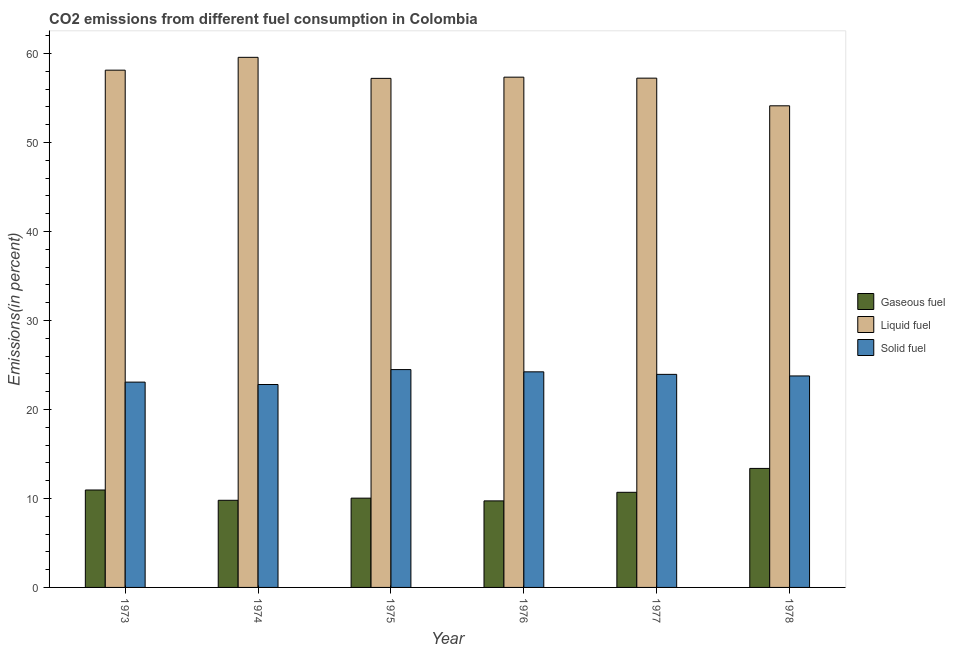How many different coloured bars are there?
Your answer should be compact. 3. Are the number of bars per tick equal to the number of legend labels?
Your response must be concise. Yes. Are the number of bars on each tick of the X-axis equal?
Ensure brevity in your answer.  Yes. What is the label of the 6th group of bars from the left?
Make the answer very short. 1978. What is the percentage of gaseous fuel emission in 1974?
Give a very brief answer. 9.79. Across all years, what is the maximum percentage of gaseous fuel emission?
Keep it short and to the point. 13.37. Across all years, what is the minimum percentage of liquid fuel emission?
Your answer should be very brief. 54.11. In which year was the percentage of gaseous fuel emission maximum?
Ensure brevity in your answer.  1978. In which year was the percentage of liquid fuel emission minimum?
Give a very brief answer. 1978. What is the total percentage of liquid fuel emission in the graph?
Make the answer very short. 343.54. What is the difference between the percentage of solid fuel emission in 1976 and that in 1977?
Keep it short and to the point. 0.28. What is the difference between the percentage of gaseous fuel emission in 1975 and the percentage of solid fuel emission in 1977?
Provide a short and direct response. -0.66. What is the average percentage of gaseous fuel emission per year?
Ensure brevity in your answer.  10.76. In the year 1974, what is the difference between the percentage of gaseous fuel emission and percentage of liquid fuel emission?
Give a very brief answer. 0. In how many years, is the percentage of solid fuel emission greater than 30 %?
Make the answer very short. 0. What is the ratio of the percentage of gaseous fuel emission in 1975 to that in 1976?
Offer a very short reply. 1.03. Is the difference between the percentage of solid fuel emission in 1973 and 1974 greater than the difference between the percentage of gaseous fuel emission in 1973 and 1974?
Offer a terse response. No. What is the difference between the highest and the second highest percentage of liquid fuel emission?
Offer a very short reply. 1.44. What is the difference between the highest and the lowest percentage of liquid fuel emission?
Your answer should be compact. 5.45. What does the 3rd bar from the left in 1977 represents?
Your answer should be very brief. Solid fuel. What does the 1st bar from the right in 1975 represents?
Offer a very short reply. Solid fuel. Is it the case that in every year, the sum of the percentage of gaseous fuel emission and percentage of liquid fuel emission is greater than the percentage of solid fuel emission?
Give a very brief answer. Yes. How many bars are there?
Provide a short and direct response. 18. Are all the bars in the graph horizontal?
Your response must be concise. No. What is the difference between two consecutive major ticks on the Y-axis?
Ensure brevity in your answer.  10. Does the graph contain grids?
Provide a short and direct response. No. Where does the legend appear in the graph?
Provide a succinct answer. Center right. How many legend labels are there?
Offer a terse response. 3. How are the legend labels stacked?
Offer a very short reply. Vertical. What is the title of the graph?
Make the answer very short. CO2 emissions from different fuel consumption in Colombia. What is the label or title of the Y-axis?
Offer a very short reply. Emissions(in percent). What is the Emissions(in percent) in Gaseous fuel in 1973?
Give a very brief answer. 10.95. What is the Emissions(in percent) in Liquid fuel in 1973?
Make the answer very short. 58.12. What is the Emissions(in percent) in Solid fuel in 1973?
Provide a short and direct response. 23.07. What is the Emissions(in percent) of Gaseous fuel in 1974?
Ensure brevity in your answer.  9.79. What is the Emissions(in percent) of Liquid fuel in 1974?
Keep it short and to the point. 59.56. What is the Emissions(in percent) of Solid fuel in 1974?
Make the answer very short. 22.8. What is the Emissions(in percent) in Gaseous fuel in 1975?
Make the answer very short. 10.03. What is the Emissions(in percent) in Liquid fuel in 1975?
Your answer should be very brief. 57.2. What is the Emissions(in percent) of Solid fuel in 1975?
Ensure brevity in your answer.  24.48. What is the Emissions(in percent) of Gaseous fuel in 1976?
Keep it short and to the point. 9.72. What is the Emissions(in percent) of Liquid fuel in 1976?
Your answer should be compact. 57.33. What is the Emissions(in percent) of Solid fuel in 1976?
Give a very brief answer. 24.22. What is the Emissions(in percent) of Gaseous fuel in 1977?
Ensure brevity in your answer.  10.69. What is the Emissions(in percent) of Liquid fuel in 1977?
Offer a terse response. 57.22. What is the Emissions(in percent) of Solid fuel in 1977?
Give a very brief answer. 23.94. What is the Emissions(in percent) of Gaseous fuel in 1978?
Provide a short and direct response. 13.37. What is the Emissions(in percent) in Liquid fuel in 1978?
Offer a terse response. 54.11. What is the Emissions(in percent) of Solid fuel in 1978?
Give a very brief answer. 23.76. Across all years, what is the maximum Emissions(in percent) of Gaseous fuel?
Your answer should be very brief. 13.37. Across all years, what is the maximum Emissions(in percent) in Liquid fuel?
Your answer should be compact. 59.56. Across all years, what is the maximum Emissions(in percent) in Solid fuel?
Your answer should be very brief. 24.48. Across all years, what is the minimum Emissions(in percent) in Gaseous fuel?
Provide a short and direct response. 9.72. Across all years, what is the minimum Emissions(in percent) in Liquid fuel?
Offer a terse response. 54.11. Across all years, what is the minimum Emissions(in percent) in Solid fuel?
Keep it short and to the point. 22.8. What is the total Emissions(in percent) of Gaseous fuel in the graph?
Keep it short and to the point. 64.55. What is the total Emissions(in percent) in Liquid fuel in the graph?
Give a very brief answer. 343.54. What is the total Emissions(in percent) in Solid fuel in the graph?
Your answer should be compact. 142.27. What is the difference between the Emissions(in percent) in Gaseous fuel in 1973 and that in 1974?
Your response must be concise. 1.16. What is the difference between the Emissions(in percent) of Liquid fuel in 1973 and that in 1974?
Provide a short and direct response. -1.44. What is the difference between the Emissions(in percent) in Solid fuel in 1973 and that in 1974?
Provide a short and direct response. 0.27. What is the difference between the Emissions(in percent) of Gaseous fuel in 1973 and that in 1975?
Ensure brevity in your answer.  0.92. What is the difference between the Emissions(in percent) of Liquid fuel in 1973 and that in 1975?
Offer a very short reply. 0.92. What is the difference between the Emissions(in percent) of Solid fuel in 1973 and that in 1975?
Ensure brevity in your answer.  -1.41. What is the difference between the Emissions(in percent) in Gaseous fuel in 1973 and that in 1976?
Your answer should be very brief. 1.22. What is the difference between the Emissions(in percent) in Liquid fuel in 1973 and that in 1976?
Ensure brevity in your answer.  0.79. What is the difference between the Emissions(in percent) in Solid fuel in 1973 and that in 1976?
Offer a terse response. -1.15. What is the difference between the Emissions(in percent) in Gaseous fuel in 1973 and that in 1977?
Give a very brief answer. 0.26. What is the difference between the Emissions(in percent) in Liquid fuel in 1973 and that in 1977?
Provide a succinct answer. 0.9. What is the difference between the Emissions(in percent) of Solid fuel in 1973 and that in 1977?
Offer a very short reply. -0.87. What is the difference between the Emissions(in percent) of Gaseous fuel in 1973 and that in 1978?
Your response must be concise. -2.43. What is the difference between the Emissions(in percent) of Liquid fuel in 1973 and that in 1978?
Offer a very short reply. 4. What is the difference between the Emissions(in percent) of Solid fuel in 1973 and that in 1978?
Make the answer very short. -0.69. What is the difference between the Emissions(in percent) in Gaseous fuel in 1974 and that in 1975?
Ensure brevity in your answer.  -0.24. What is the difference between the Emissions(in percent) in Liquid fuel in 1974 and that in 1975?
Your answer should be very brief. 2.36. What is the difference between the Emissions(in percent) in Solid fuel in 1974 and that in 1975?
Your response must be concise. -1.68. What is the difference between the Emissions(in percent) in Gaseous fuel in 1974 and that in 1976?
Your answer should be very brief. 0.07. What is the difference between the Emissions(in percent) of Liquid fuel in 1974 and that in 1976?
Ensure brevity in your answer.  2.23. What is the difference between the Emissions(in percent) of Solid fuel in 1974 and that in 1976?
Your answer should be compact. -1.42. What is the difference between the Emissions(in percent) in Gaseous fuel in 1974 and that in 1977?
Offer a terse response. -0.9. What is the difference between the Emissions(in percent) in Liquid fuel in 1974 and that in 1977?
Provide a succinct answer. 2.34. What is the difference between the Emissions(in percent) of Solid fuel in 1974 and that in 1977?
Offer a terse response. -1.14. What is the difference between the Emissions(in percent) in Gaseous fuel in 1974 and that in 1978?
Provide a succinct answer. -3.58. What is the difference between the Emissions(in percent) of Liquid fuel in 1974 and that in 1978?
Your answer should be very brief. 5.45. What is the difference between the Emissions(in percent) in Solid fuel in 1974 and that in 1978?
Provide a short and direct response. -0.96. What is the difference between the Emissions(in percent) of Gaseous fuel in 1975 and that in 1976?
Your answer should be very brief. 0.31. What is the difference between the Emissions(in percent) in Liquid fuel in 1975 and that in 1976?
Offer a terse response. -0.13. What is the difference between the Emissions(in percent) in Solid fuel in 1975 and that in 1976?
Your response must be concise. 0.25. What is the difference between the Emissions(in percent) of Gaseous fuel in 1975 and that in 1977?
Ensure brevity in your answer.  -0.66. What is the difference between the Emissions(in percent) of Liquid fuel in 1975 and that in 1977?
Provide a succinct answer. -0.02. What is the difference between the Emissions(in percent) of Solid fuel in 1975 and that in 1977?
Ensure brevity in your answer.  0.54. What is the difference between the Emissions(in percent) of Gaseous fuel in 1975 and that in 1978?
Provide a succinct answer. -3.34. What is the difference between the Emissions(in percent) of Liquid fuel in 1975 and that in 1978?
Your response must be concise. 3.08. What is the difference between the Emissions(in percent) in Solid fuel in 1975 and that in 1978?
Provide a succinct answer. 0.71. What is the difference between the Emissions(in percent) of Gaseous fuel in 1976 and that in 1977?
Offer a very short reply. -0.96. What is the difference between the Emissions(in percent) of Liquid fuel in 1976 and that in 1977?
Your answer should be very brief. 0.11. What is the difference between the Emissions(in percent) in Solid fuel in 1976 and that in 1977?
Offer a terse response. 0.28. What is the difference between the Emissions(in percent) in Gaseous fuel in 1976 and that in 1978?
Your answer should be very brief. -3.65. What is the difference between the Emissions(in percent) of Liquid fuel in 1976 and that in 1978?
Ensure brevity in your answer.  3.22. What is the difference between the Emissions(in percent) in Solid fuel in 1976 and that in 1978?
Your answer should be compact. 0.46. What is the difference between the Emissions(in percent) in Gaseous fuel in 1977 and that in 1978?
Your answer should be very brief. -2.68. What is the difference between the Emissions(in percent) of Liquid fuel in 1977 and that in 1978?
Make the answer very short. 3.11. What is the difference between the Emissions(in percent) in Solid fuel in 1977 and that in 1978?
Your response must be concise. 0.18. What is the difference between the Emissions(in percent) in Gaseous fuel in 1973 and the Emissions(in percent) in Liquid fuel in 1974?
Your answer should be compact. -48.61. What is the difference between the Emissions(in percent) of Gaseous fuel in 1973 and the Emissions(in percent) of Solid fuel in 1974?
Keep it short and to the point. -11.85. What is the difference between the Emissions(in percent) in Liquid fuel in 1973 and the Emissions(in percent) in Solid fuel in 1974?
Ensure brevity in your answer.  35.32. What is the difference between the Emissions(in percent) of Gaseous fuel in 1973 and the Emissions(in percent) of Liquid fuel in 1975?
Give a very brief answer. -46.25. What is the difference between the Emissions(in percent) of Gaseous fuel in 1973 and the Emissions(in percent) of Solid fuel in 1975?
Your response must be concise. -13.53. What is the difference between the Emissions(in percent) of Liquid fuel in 1973 and the Emissions(in percent) of Solid fuel in 1975?
Offer a terse response. 33.64. What is the difference between the Emissions(in percent) of Gaseous fuel in 1973 and the Emissions(in percent) of Liquid fuel in 1976?
Offer a very short reply. -46.38. What is the difference between the Emissions(in percent) in Gaseous fuel in 1973 and the Emissions(in percent) in Solid fuel in 1976?
Give a very brief answer. -13.28. What is the difference between the Emissions(in percent) in Liquid fuel in 1973 and the Emissions(in percent) in Solid fuel in 1976?
Give a very brief answer. 33.89. What is the difference between the Emissions(in percent) in Gaseous fuel in 1973 and the Emissions(in percent) in Liquid fuel in 1977?
Offer a very short reply. -46.27. What is the difference between the Emissions(in percent) of Gaseous fuel in 1973 and the Emissions(in percent) of Solid fuel in 1977?
Your response must be concise. -12.99. What is the difference between the Emissions(in percent) in Liquid fuel in 1973 and the Emissions(in percent) in Solid fuel in 1977?
Make the answer very short. 34.18. What is the difference between the Emissions(in percent) in Gaseous fuel in 1973 and the Emissions(in percent) in Liquid fuel in 1978?
Keep it short and to the point. -43.17. What is the difference between the Emissions(in percent) in Gaseous fuel in 1973 and the Emissions(in percent) in Solid fuel in 1978?
Your answer should be compact. -12.82. What is the difference between the Emissions(in percent) of Liquid fuel in 1973 and the Emissions(in percent) of Solid fuel in 1978?
Make the answer very short. 34.36. What is the difference between the Emissions(in percent) in Gaseous fuel in 1974 and the Emissions(in percent) in Liquid fuel in 1975?
Ensure brevity in your answer.  -47.41. What is the difference between the Emissions(in percent) of Gaseous fuel in 1974 and the Emissions(in percent) of Solid fuel in 1975?
Make the answer very short. -14.69. What is the difference between the Emissions(in percent) in Liquid fuel in 1974 and the Emissions(in percent) in Solid fuel in 1975?
Give a very brief answer. 35.08. What is the difference between the Emissions(in percent) of Gaseous fuel in 1974 and the Emissions(in percent) of Liquid fuel in 1976?
Provide a short and direct response. -47.54. What is the difference between the Emissions(in percent) in Gaseous fuel in 1974 and the Emissions(in percent) in Solid fuel in 1976?
Offer a terse response. -14.43. What is the difference between the Emissions(in percent) of Liquid fuel in 1974 and the Emissions(in percent) of Solid fuel in 1976?
Keep it short and to the point. 35.34. What is the difference between the Emissions(in percent) of Gaseous fuel in 1974 and the Emissions(in percent) of Liquid fuel in 1977?
Provide a short and direct response. -47.43. What is the difference between the Emissions(in percent) in Gaseous fuel in 1974 and the Emissions(in percent) in Solid fuel in 1977?
Provide a short and direct response. -14.15. What is the difference between the Emissions(in percent) in Liquid fuel in 1974 and the Emissions(in percent) in Solid fuel in 1977?
Your response must be concise. 35.62. What is the difference between the Emissions(in percent) of Gaseous fuel in 1974 and the Emissions(in percent) of Liquid fuel in 1978?
Provide a succinct answer. -44.32. What is the difference between the Emissions(in percent) in Gaseous fuel in 1974 and the Emissions(in percent) in Solid fuel in 1978?
Offer a very short reply. -13.97. What is the difference between the Emissions(in percent) of Liquid fuel in 1974 and the Emissions(in percent) of Solid fuel in 1978?
Your response must be concise. 35.8. What is the difference between the Emissions(in percent) of Gaseous fuel in 1975 and the Emissions(in percent) of Liquid fuel in 1976?
Keep it short and to the point. -47.3. What is the difference between the Emissions(in percent) of Gaseous fuel in 1975 and the Emissions(in percent) of Solid fuel in 1976?
Offer a very short reply. -14.19. What is the difference between the Emissions(in percent) of Liquid fuel in 1975 and the Emissions(in percent) of Solid fuel in 1976?
Give a very brief answer. 32.97. What is the difference between the Emissions(in percent) in Gaseous fuel in 1975 and the Emissions(in percent) in Liquid fuel in 1977?
Offer a terse response. -47.19. What is the difference between the Emissions(in percent) in Gaseous fuel in 1975 and the Emissions(in percent) in Solid fuel in 1977?
Ensure brevity in your answer.  -13.91. What is the difference between the Emissions(in percent) of Liquid fuel in 1975 and the Emissions(in percent) of Solid fuel in 1977?
Ensure brevity in your answer.  33.26. What is the difference between the Emissions(in percent) in Gaseous fuel in 1975 and the Emissions(in percent) in Liquid fuel in 1978?
Your response must be concise. -44.08. What is the difference between the Emissions(in percent) of Gaseous fuel in 1975 and the Emissions(in percent) of Solid fuel in 1978?
Ensure brevity in your answer.  -13.73. What is the difference between the Emissions(in percent) of Liquid fuel in 1975 and the Emissions(in percent) of Solid fuel in 1978?
Your answer should be compact. 33.44. What is the difference between the Emissions(in percent) of Gaseous fuel in 1976 and the Emissions(in percent) of Liquid fuel in 1977?
Provide a short and direct response. -47.5. What is the difference between the Emissions(in percent) of Gaseous fuel in 1976 and the Emissions(in percent) of Solid fuel in 1977?
Offer a terse response. -14.21. What is the difference between the Emissions(in percent) of Liquid fuel in 1976 and the Emissions(in percent) of Solid fuel in 1977?
Provide a succinct answer. 33.39. What is the difference between the Emissions(in percent) in Gaseous fuel in 1976 and the Emissions(in percent) in Liquid fuel in 1978?
Ensure brevity in your answer.  -44.39. What is the difference between the Emissions(in percent) in Gaseous fuel in 1976 and the Emissions(in percent) in Solid fuel in 1978?
Make the answer very short. -14.04. What is the difference between the Emissions(in percent) of Liquid fuel in 1976 and the Emissions(in percent) of Solid fuel in 1978?
Provide a short and direct response. 33.57. What is the difference between the Emissions(in percent) of Gaseous fuel in 1977 and the Emissions(in percent) of Liquid fuel in 1978?
Provide a succinct answer. -43.43. What is the difference between the Emissions(in percent) in Gaseous fuel in 1977 and the Emissions(in percent) in Solid fuel in 1978?
Keep it short and to the point. -13.07. What is the difference between the Emissions(in percent) of Liquid fuel in 1977 and the Emissions(in percent) of Solid fuel in 1978?
Ensure brevity in your answer.  33.46. What is the average Emissions(in percent) of Gaseous fuel per year?
Your answer should be compact. 10.76. What is the average Emissions(in percent) of Liquid fuel per year?
Give a very brief answer. 57.26. What is the average Emissions(in percent) in Solid fuel per year?
Make the answer very short. 23.71. In the year 1973, what is the difference between the Emissions(in percent) of Gaseous fuel and Emissions(in percent) of Liquid fuel?
Your response must be concise. -47.17. In the year 1973, what is the difference between the Emissions(in percent) in Gaseous fuel and Emissions(in percent) in Solid fuel?
Provide a short and direct response. -12.12. In the year 1973, what is the difference between the Emissions(in percent) of Liquid fuel and Emissions(in percent) of Solid fuel?
Ensure brevity in your answer.  35.05. In the year 1974, what is the difference between the Emissions(in percent) in Gaseous fuel and Emissions(in percent) in Liquid fuel?
Offer a terse response. -49.77. In the year 1974, what is the difference between the Emissions(in percent) in Gaseous fuel and Emissions(in percent) in Solid fuel?
Ensure brevity in your answer.  -13.01. In the year 1974, what is the difference between the Emissions(in percent) of Liquid fuel and Emissions(in percent) of Solid fuel?
Your response must be concise. 36.76. In the year 1975, what is the difference between the Emissions(in percent) in Gaseous fuel and Emissions(in percent) in Liquid fuel?
Your answer should be very brief. -47.17. In the year 1975, what is the difference between the Emissions(in percent) of Gaseous fuel and Emissions(in percent) of Solid fuel?
Give a very brief answer. -14.44. In the year 1975, what is the difference between the Emissions(in percent) of Liquid fuel and Emissions(in percent) of Solid fuel?
Provide a short and direct response. 32.72. In the year 1976, what is the difference between the Emissions(in percent) in Gaseous fuel and Emissions(in percent) in Liquid fuel?
Keep it short and to the point. -47.61. In the year 1976, what is the difference between the Emissions(in percent) in Gaseous fuel and Emissions(in percent) in Solid fuel?
Offer a terse response. -14.5. In the year 1976, what is the difference between the Emissions(in percent) of Liquid fuel and Emissions(in percent) of Solid fuel?
Keep it short and to the point. 33.11. In the year 1977, what is the difference between the Emissions(in percent) of Gaseous fuel and Emissions(in percent) of Liquid fuel?
Ensure brevity in your answer.  -46.53. In the year 1977, what is the difference between the Emissions(in percent) of Gaseous fuel and Emissions(in percent) of Solid fuel?
Ensure brevity in your answer.  -13.25. In the year 1977, what is the difference between the Emissions(in percent) of Liquid fuel and Emissions(in percent) of Solid fuel?
Offer a terse response. 33.28. In the year 1978, what is the difference between the Emissions(in percent) in Gaseous fuel and Emissions(in percent) in Liquid fuel?
Ensure brevity in your answer.  -40.74. In the year 1978, what is the difference between the Emissions(in percent) of Gaseous fuel and Emissions(in percent) of Solid fuel?
Ensure brevity in your answer.  -10.39. In the year 1978, what is the difference between the Emissions(in percent) in Liquid fuel and Emissions(in percent) in Solid fuel?
Provide a short and direct response. 30.35. What is the ratio of the Emissions(in percent) in Gaseous fuel in 1973 to that in 1974?
Provide a short and direct response. 1.12. What is the ratio of the Emissions(in percent) in Liquid fuel in 1973 to that in 1974?
Your answer should be very brief. 0.98. What is the ratio of the Emissions(in percent) of Solid fuel in 1973 to that in 1974?
Your response must be concise. 1.01. What is the ratio of the Emissions(in percent) of Gaseous fuel in 1973 to that in 1975?
Ensure brevity in your answer.  1.09. What is the ratio of the Emissions(in percent) in Liquid fuel in 1973 to that in 1975?
Offer a terse response. 1.02. What is the ratio of the Emissions(in percent) in Solid fuel in 1973 to that in 1975?
Provide a succinct answer. 0.94. What is the ratio of the Emissions(in percent) in Gaseous fuel in 1973 to that in 1976?
Your answer should be compact. 1.13. What is the ratio of the Emissions(in percent) of Liquid fuel in 1973 to that in 1976?
Provide a succinct answer. 1.01. What is the ratio of the Emissions(in percent) in Gaseous fuel in 1973 to that in 1977?
Give a very brief answer. 1.02. What is the ratio of the Emissions(in percent) of Liquid fuel in 1973 to that in 1977?
Keep it short and to the point. 1.02. What is the ratio of the Emissions(in percent) in Solid fuel in 1973 to that in 1977?
Make the answer very short. 0.96. What is the ratio of the Emissions(in percent) of Gaseous fuel in 1973 to that in 1978?
Give a very brief answer. 0.82. What is the ratio of the Emissions(in percent) in Liquid fuel in 1973 to that in 1978?
Your answer should be compact. 1.07. What is the ratio of the Emissions(in percent) in Solid fuel in 1973 to that in 1978?
Provide a short and direct response. 0.97. What is the ratio of the Emissions(in percent) in Liquid fuel in 1974 to that in 1975?
Provide a short and direct response. 1.04. What is the ratio of the Emissions(in percent) in Solid fuel in 1974 to that in 1975?
Offer a very short reply. 0.93. What is the ratio of the Emissions(in percent) in Gaseous fuel in 1974 to that in 1976?
Offer a terse response. 1.01. What is the ratio of the Emissions(in percent) in Liquid fuel in 1974 to that in 1976?
Offer a terse response. 1.04. What is the ratio of the Emissions(in percent) in Solid fuel in 1974 to that in 1976?
Offer a terse response. 0.94. What is the ratio of the Emissions(in percent) of Gaseous fuel in 1974 to that in 1977?
Your response must be concise. 0.92. What is the ratio of the Emissions(in percent) of Liquid fuel in 1974 to that in 1977?
Make the answer very short. 1.04. What is the ratio of the Emissions(in percent) of Solid fuel in 1974 to that in 1977?
Make the answer very short. 0.95. What is the ratio of the Emissions(in percent) in Gaseous fuel in 1974 to that in 1978?
Make the answer very short. 0.73. What is the ratio of the Emissions(in percent) of Liquid fuel in 1974 to that in 1978?
Make the answer very short. 1.1. What is the ratio of the Emissions(in percent) of Solid fuel in 1974 to that in 1978?
Provide a short and direct response. 0.96. What is the ratio of the Emissions(in percent) of Gaseous fuel in 1975 to that in 1976?
Offer a terse response. 1.03. What is the ratio of the Emissions(in percent) of Liquid fuel in 1975 to that in 1976?
Ensure brevity in your answer.  1. What is the ratio of the Emissions(in percent) in Solid fuel in 1975 to that in 1976?
Offer a very short reply. 1.01. What is the ratio of the Emissions(in percent) in Gaseous fuel in 1975 to that in 1977?
Your answer should be compact. 0.94. What is the ratio of the Emissions(in percent) in Solid fuel in 1975 to that in 1977?
Provide a short and direct response. 1.02. What is the ratio of the Emissions(in percent) of Gaseous fuel in 1975 to that in 1978?
Your answer should be very brief. 0.75. What is the ratio of the Emissions(in percent) in Liquid fuel in 1975 to that in 1978?
Offer a very short reply. 1.06. What is the ratio of the Emissions(in percent) of Solid fuel in 1975 to that in 1978?
Offer a very short reply. 1.03. What is the ratio of the Emissions(in percent) in Gaseous fuel in 1976 to that in 1977?
Provide a succinct answer. 0.91. What is the ratio of the Emissions(in percent) of Liquid fuel in 1976 to that in 1977?
Make the answer very short. 1. What is the ratio of the Emissions(in percent) in Solid fuel in 1976 to that in 1977?
Provide a short and direct response. 1.01. What is the ratio of the Emissions(in percent) in Gaseous fuel in 1976 to that in 1978?
Your answer should be compact. 0.73. What is the ratio of the Emissions(in percent) of Liquid fuel in 1976 to that in 1978?
Offer a terse response. 1.06. What is the ratio of the Emissions(in percent) of Solid fuel in 1976 to that in 1978?
Your answer should be very brief. 1.02. What is the ratio of the Emissions(in percent) in Gaseous fuel in 1977 to that in 1978?
Make the answer very short. 0.8. What is the ratio of the Emissions(in percent) in Liquid fuel in 1977 to that in 1978?
Give a very brief answer. 1.06. What is the ratio of the Emissions(in percent) of Solid fuel in 1977 to that in 1978?
Keep it short and to the point. 1.01. What is the difference between the highest and the second highest Emissions(in percent) of Gaseous fuel?
Give a very brief answer. 2.43. What is the difference between the highest and the second highest Emissions(in percent) of Liquid fuel?
Provide a short and direct response. 1.44. What is the difference between the highest and the second highest Emissions(in percent) in Solid fuel?
Ensure brevity in your answer.  0.25. What is the difference between the highest and the lowest Emissions(in percent) of Gaseous fuel?
Provide a short and direct response. 3.65. What is the difference between the highest and the lowest Emissions(in percent) in Liquid fuel?
Offer a very short reply. 5.45. What is the difference between the highest and the lowest Emissions(in percent) of Solid fuel?
Make the answer very short. 1.68. 